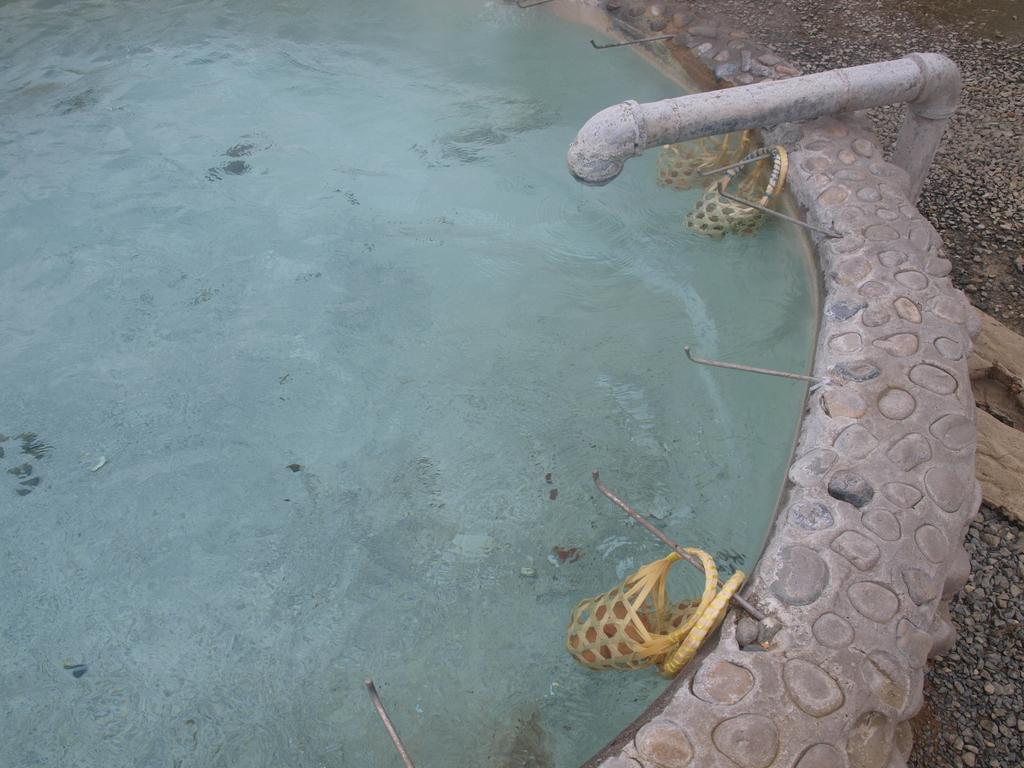In one or two sentences, can you explain what this image depicts? This picture is clicked outside. In the center there is a swimming pool and we can see a metal pipe and some objects in the pool. On the right corner we can see the gravels and some other objects. 